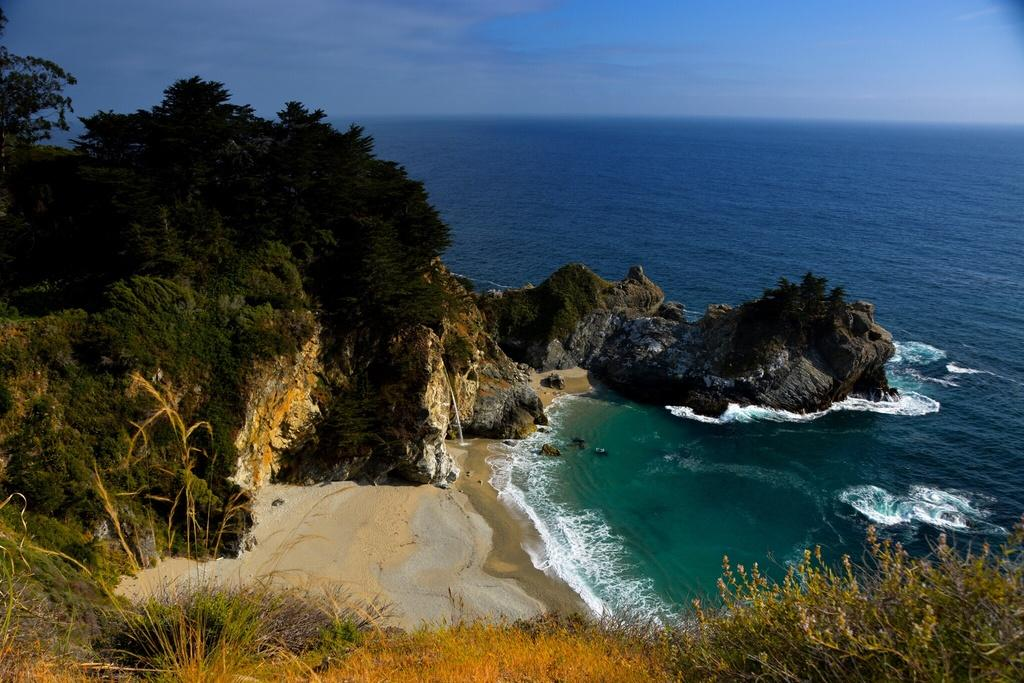What type of natural feature is located on the right side of the image? There is a river on the right side of the image. What type of natural feature is located on the left side of the image? There is a mountain on the left side of the image. What can be found on the mountain in the image? There are algae and trees on the mountain. What is visible in the background of the image? The sky is visible in the background of the image. What type of curtain can be seen hanging from the trees on the mountain? There are no curtains present in the image; the trees on the mountain have leaves and branches. What type of animal is sitting on the algae on the mountain? There are no animals visible in the image; the mountain only features algae and trees. 